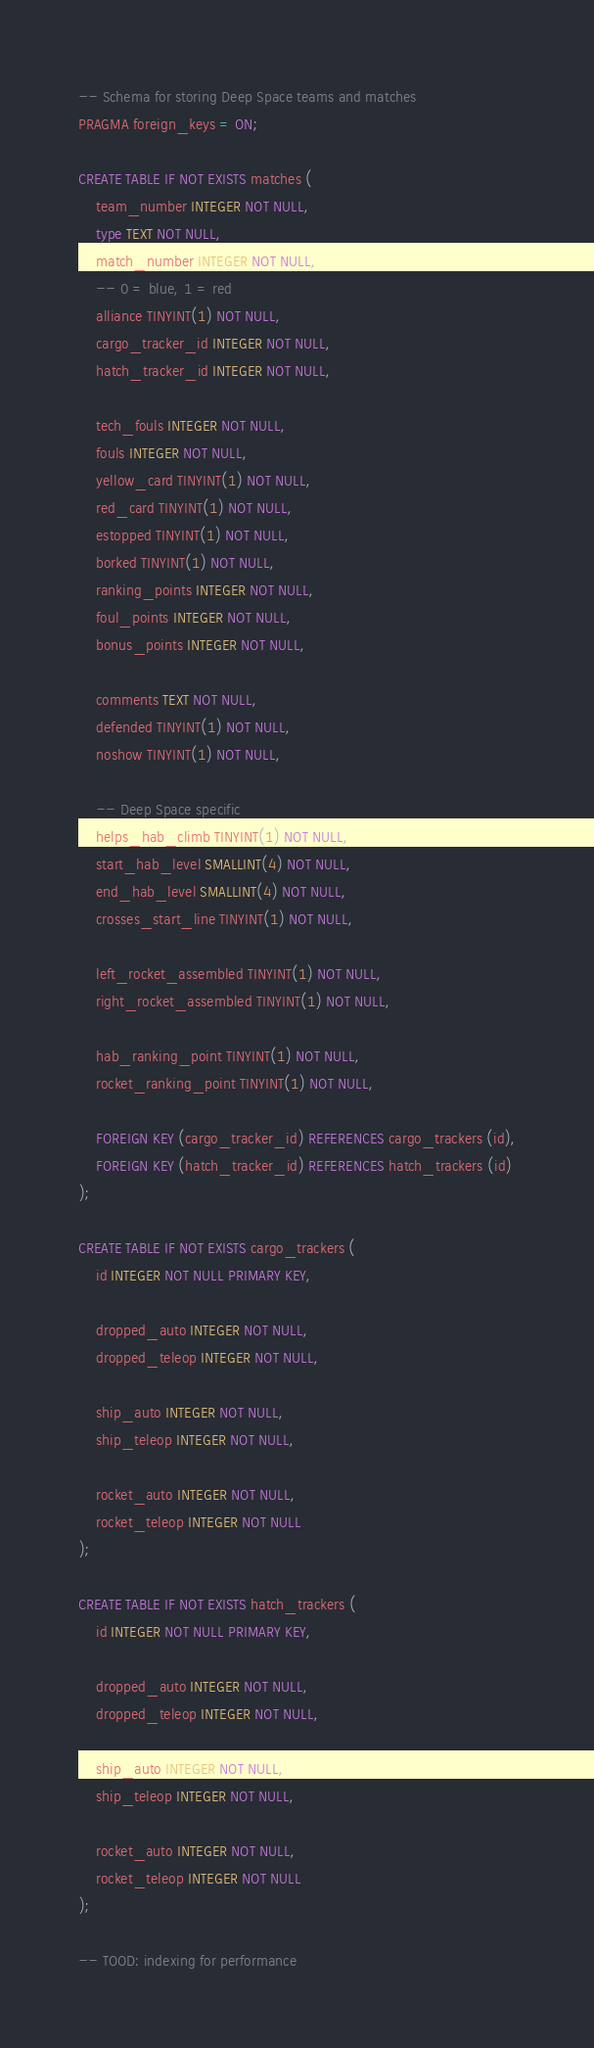Convert code to text. <code><loc_0><loc_0><loc_500><loc_500><_SQL_>-- Schema for storing Deep Space teams and matches
PRAGMA foreign_keys = ON;

CREATE TABLE IF NOT EXISTS matches (
    team_number INTEGER NOT NULL,
    type TEXT NOT NULL,
    match_number INTEGER NOT NULL,
    -- 0 = blue, 1 = red
    alliance TINYINT(1) NOT NULL,
    cargo_tracker_id INTEGER NOT NULL,
    hatch_tracker_id INTEGER NOT NULL,

    tech_fouls INTEGER NOT NULL,
    fouls INTEGER NOT NULL,
    yellow_card TINYINT(1) NOT NULL,
    red_card TINYINT(1) NOT NULL,
    estopped TINYINT(1) NOT NULL,
    borked TINYINT(1) NOT NULL,
    ranking_points INTEGER NOT NULL,
    foul_points INTEGER NOT NULL,
    bonus_points INTEGER NOT NULL,

    comments TEXT NOT NULL,
    defended TINYINT(1) NOT NULL,
    noshow TINYINT(1) NOT NULL,

    -- Deep Space specific
    helps_hab_climb TINYINT(1) NOT NULL,
    start_hab_level SMALLINT(4) NOT NULL,
    end_hab_level SMALLINT(4) NOT NULL,
    crosses_start_line TINYINT(1) NOT NULL,

    left_rocket_assembled TINYINT(1) NOT NULL,
    right_rocket_assembled TINYINT(1) NOT NULL,

    hab_ranking_point TINYINT(1) NOT NULL,
    rocket_ranking_point TINYINT(1) NOT NULL,

    FOREIGN KEY (cargo_tracker_id) REFERENCES cargo_trackers (id),
    FOREIGN KEY (hatch_tracker_id) REFERENCES hatch_trackers (id)
);

CREATE TABLE IF NOT EXISTS cargo_trackers (
    id INTEGER NOT NULL PRIMARY KEY,

    dropped_auto INTEGER NOT NULL,
    dropped_teleop INTEGER NOT NULL,

    ship_auto INTEGER NOT NULL,
    ship_teleop INTEGER NOT NULL,

    rocket_auto INTEGER NOT NULL,
    rocket_teleop INTEGER NOT NULL
);

CREATE TABLE IF NOT EXISTS hatch_trackers (
    id INTEGER NOT NULL PRIMARY KEY,

    dropped_auto INTEGER NOT NULL,
    dropped_teleop INTEGER NOT NULL,

    ship_auto INTEGER NOT NULL,
    ship_teleop INTEGER NOT NULL,

    rocket_auto INTEGER NOT NULL,
    rocket_teleop INTEGER NOT NULL
);

-- TOOD: indexing for performance
</code> 